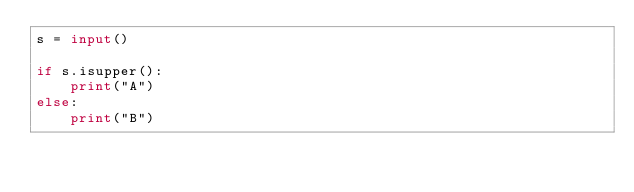<code> <loc_0><loc_0><loc_500><loc_500><_Python_>s = input()

if s.isupper():
    print("A")
else:
    print("B")




</code> 